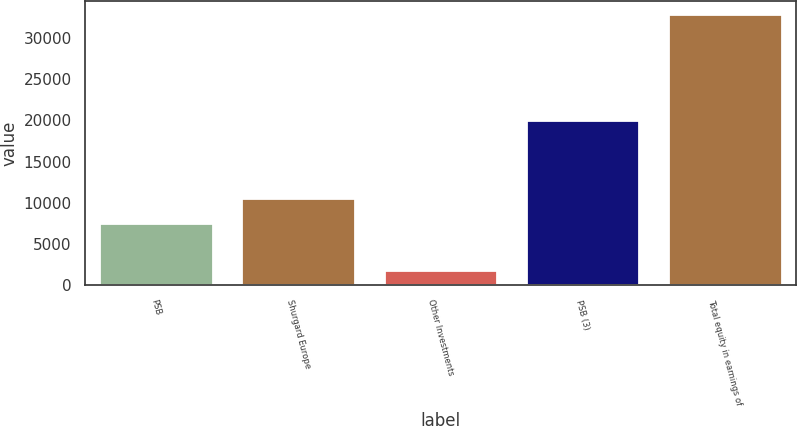<chart> <loc_0><loc_0><loc_500><loc_500><bar_chart><fcel>PSB<fcel>Shurgard Europe<fcel>Other Investments<fcel>PSB (3)<fcel>Total equity in earnings of<nl><fcel>7542<fcel>10636<fcel>1913<fcel>20070<fcel>32853<nl></chart> 